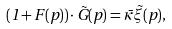Convert formula to latex. <formula><loc_0><loc_0><loc_500><loc_500>( 1 + F ( p ) ) \cdot \tilde { G } ( p ) = \bar { \kappa } \tilde { \xi } ( p ) ,</formula> 